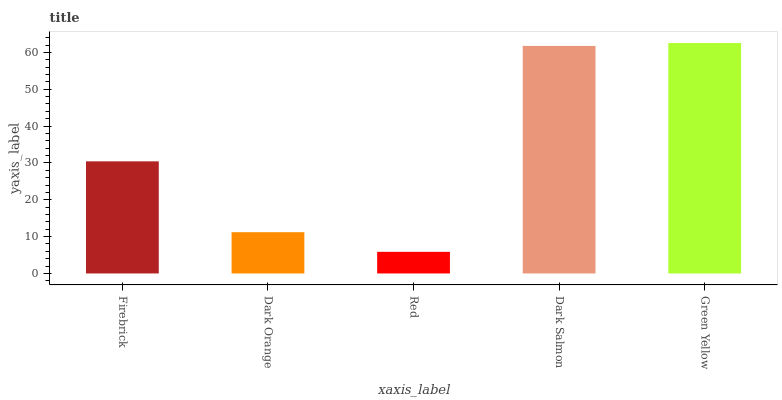Is Red the minimum?
Answer yes or no. Yes. Is Green Yellow the maximum?
Answer yes or no. Yes. Is Dark Orange the minimum?
Answer yes or no. No. Is Dark Orange the maximum?
Answer yes or no. No. Is Firebrick greater than Dark Orange?
Answer yes or no. Yes. Is Dark Orange less than Firebrick?
Answer yes or no. Yes. Is Dark Orange greater than Firebrick?
Answer yes or no. No. Is Firebrick less than Dark Orange?
Answer yes or no. No. Is Firebrick the high median?
Answer yes or no. Yes. Is Firebrick the low median?
Answer yes or no. Yes. Is Green Yellow the high median?
Answer yes or no. No. Is Red the low median?
Answer yes or no. No. 